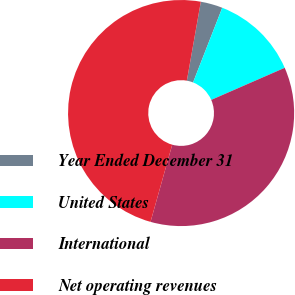Convert chart. <chart><loc_0><loc_0><loc_500><loc_500><pie_chart><fcel>Year Ended December 31<fcel>United States<fcel>International<fcel>Net operating revenues<nl><fcel>3.14%<fcel>12.52%<fcel>35.91%<fcel>48.43%<nl></chart> 